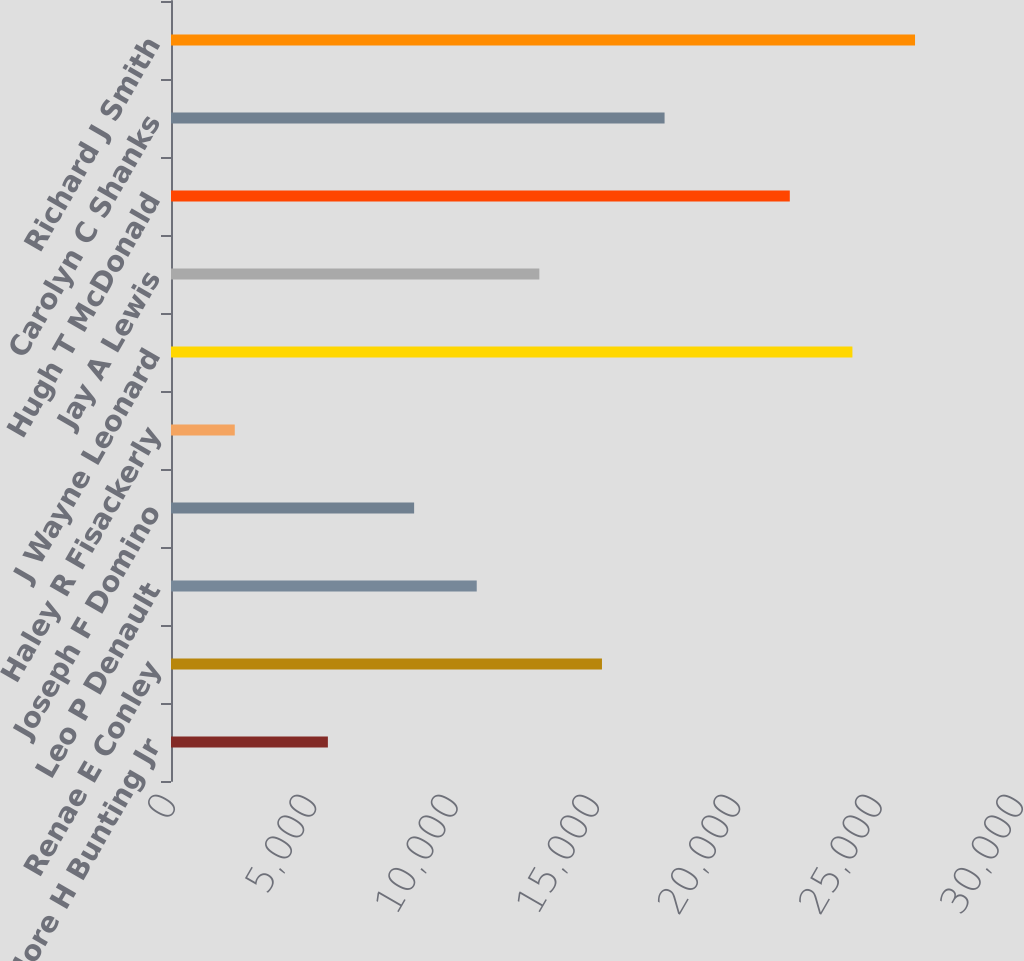Convert chart. <chart><loc_0><loc_0><loc_500><loc_500><bar_chart><fcel>Theodore H Bunting Jr<fcel>Renae E Conley<fcel>Leo P Denault<fcel>Joseph F Domino<fcel>Haley R Fisackerly<fcel>J Wayne Leonard<fcel>Jay A Lewis<fcel>Hugh T McDonald<fcel>Carolyn C Shanks<fcel>Richard J Smith<nl><fcel>5550<fcel>15246.3<fcel>10816.1<fcel>8601<fcel>2256<fcel>24106.7<fcel>13031.2<fcel>21891.6<fcel>17461.4<fcel>26321.8<nl></chart> 